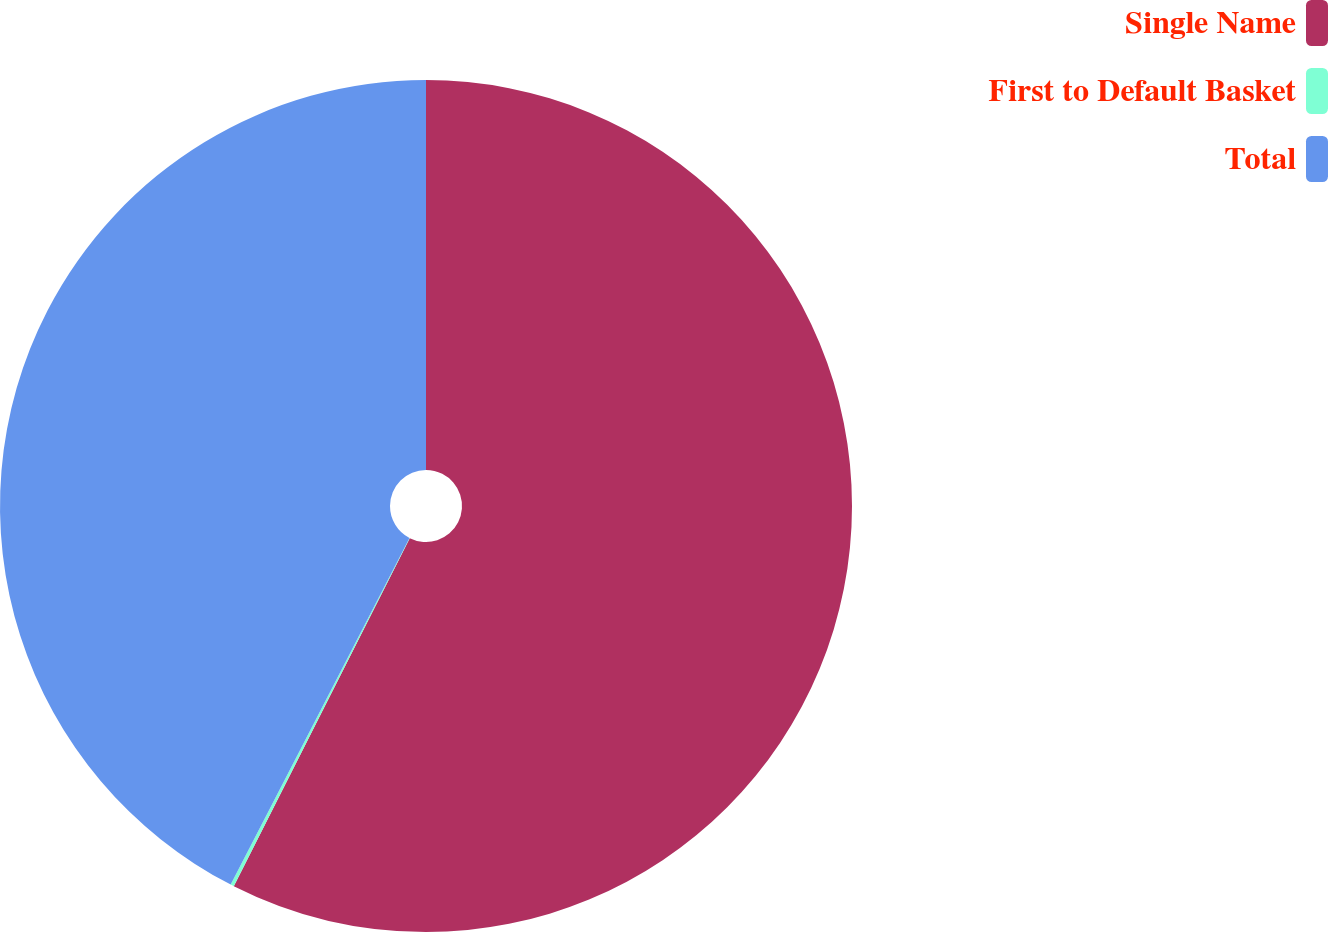Convert chart. <chart><loc_0><loc_0><loc_500><loc_500><pie_chart><fcel>Single Name<fcel>First to Default Basket<fcel>Total<nl><fcel>57.45%<fcel>0.13%<fcel>42.42%<nl></chart> 